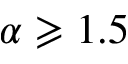<formula> <loc_0><loc_0><loc_500><loc_500>\alpha \geqslant 1 . 5</formula> 